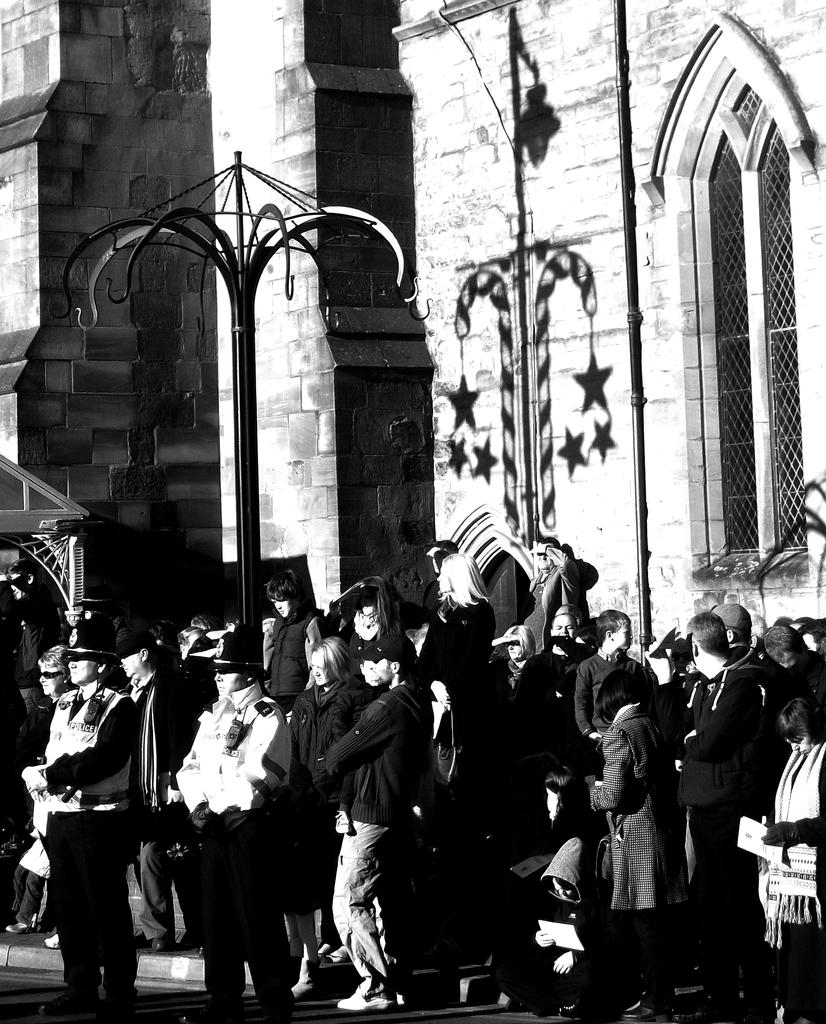Who or what can be seen in the image? There are people in the image. What is located on the path in the image? There is a stand on the path. What type of structure is visible in the image? There is a building in the image. Where is the window located in the image? There is a window on the right side of the image. What type of lettuce is being sold at the stand in the image? There is no lettuce present in the image, nor is there any indication of a stand selling lettuce. 